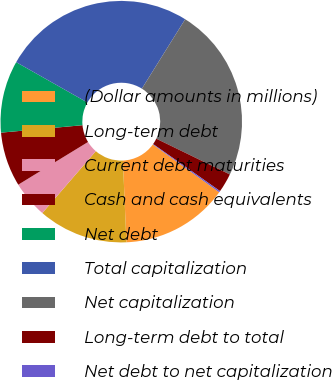Convert chart. <chart><loc_0><loc_0><loc_500><loc_500><pie_chart><fcel>(Dollar amounts in millions)<fcel>Long-term debt<fcel>Current debt maturities<fcel>Cash and cash equivalents<fcel>Net debt<fcel>Total capitalization<fcel>Net capitalization<fcel>Long-term debt to total<fcel>Net debt to net capitalization<nl><fcel>14.38%<fcel>12.02%<fcel>4.92%<fcel>7.29%<fcel>9.65%<fcel>25.68%<fcel>23.32%<fcel>2.55%<fcel>0.19%<nl></chart> 